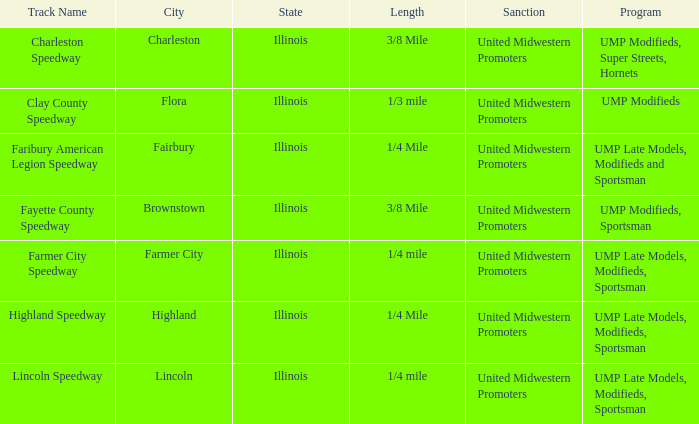What location is farmer city speedway? Farmer City, Illinois. 